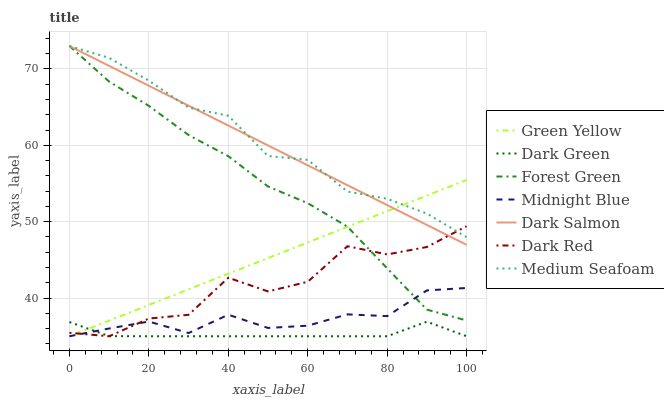Does Dark Green have the minimum area under the curve?
Answer yes or no. Yes. Does Medium Seafoam have the maximum area under the curve?
Answer yes or no. Yes. Does Dark Red have the minimum area under the curve?
Answer yes or no. No. Does Dark Red have the maximum area under the curve?
Answer yes or no. No. Is Green Yellow the smoothest?
Answer yes or no. Yes. Is Dark Red the roughest?
Answer yes or no. Yes. Is Dark Salmon the smoothest?
Answer yes or no. No. Is Dark Salmon the roughest?
Answer yes or no. No. Does Midnight Blue have the lowest value?
Answer yes or no. Yes. Does Dark Salmon have the lowest value?
Answer yes or no. No. Does Medium Seafoam have the highest value?
Answer yes or no. Yes. Does Dark Red have the highest value?
Answer yes or no. No. Is Midnight Blue less than Medium Seafoam?
Answer yes or no. Yes. Is Dark Salmon greater than Midnight Blue?
Answer yes or no. Yes. Does Forest Green intersect Green Yellow?
Answer yes or no. Yes. Is Forest Green less than Green Yellow?
Answer yes or no. No. Is Forest Green greater than Green Yellow?
Answer yes or no. No. Does Midnight Blue intersect Medium Seafoam?
Answer yes or no. No. 